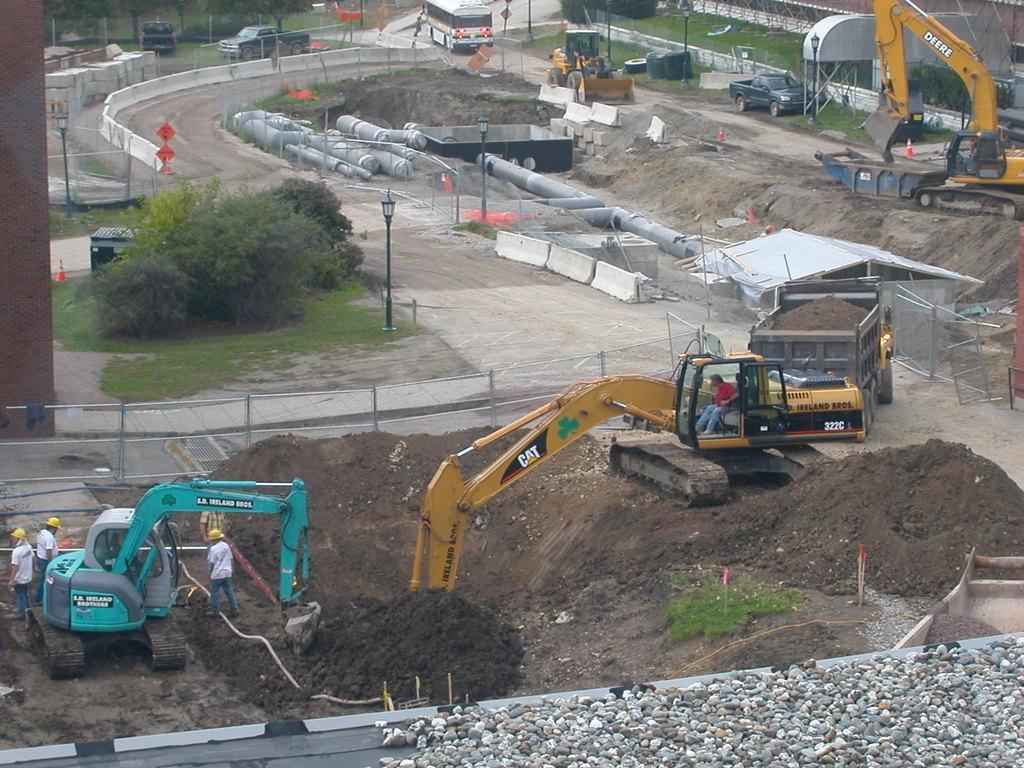Could you give a brief overview of what you see in this image? In this image I can see fleets of vehicles, cranes, group of people on the ground, pipes, light poles, mud and concrete. In the background I can see trees. This image is taken may be during a day. 